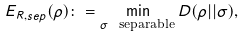Convert formula to latex. <formula><loc_0><loc_0><loc_500><loc_500>E _ { R , s e p } ( \rho ) \colon = \min _ { \sigma \ \text {separable} } D ( \rho | | \sigma ) ,</formula> 